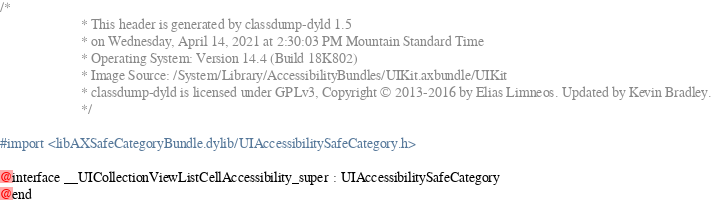Convert code to text. <code><loc_0><loc_0><loc_500><loc_500><_C_>/*
                       * This header is generated by classdump-dyld 1.5
                       * on Wednesday, April 14, 2021 at 2:30:03 PM Mountain Standard Time
                       * Operating System: Version 14.4 (Build 18K802)
                       * Image Source: /System/Library/AccessibilityBundles/UIKit.axbundle/UIKit
                       * classdump-dyld is licensed under GPLv3, Copyright © 2013-2016 by Elias Limneos. Updated by Kevin Bradley.
                       */

#import <libAXSafeCategoryBundle.dylib/UIAccessibilitySafeCategory.h>

@interface __UICollectionViewListCellAccessibility_super : UIAccessibilitySafeCategory
@end

</code> 